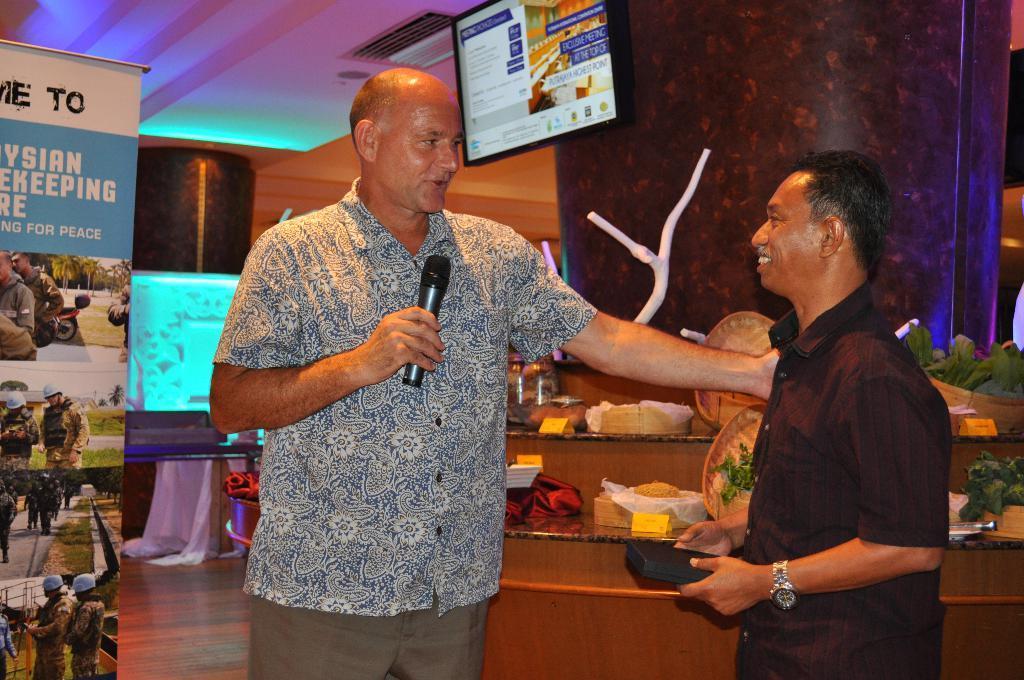How would you summarize this image in a sentence or two? In this picture we can observe two men standing. One of them is holding a mic in his hand and other is smiling. On the left side we can observe a poster. We can observe a television fixed to the ceiling. There is a brown color pillar. In the background can observe lights on the ceiling. 